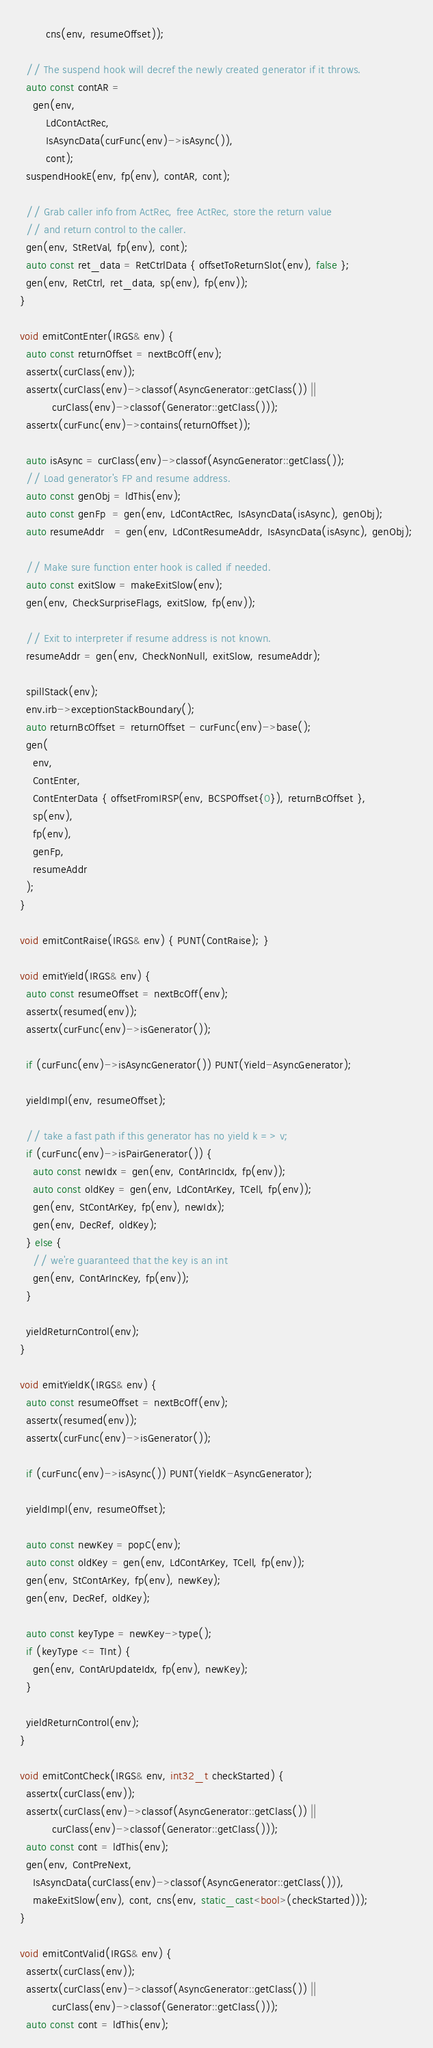<code> <loc_0><loc_0><loc_500><loc_500><_C++_>        cns(env, resumeOffset));

  // The suspend hook will decref the newly created generator if it throws.
  auto const contAR =
    gen(env,
        LdContActRec,
        IsAsyncData(curFunc(env)->isAsync()),
        cont);
  suspendHookE(env, fp(env), contAR, cont);

  // Grab caller info from ActRec, free ActRec, store the return value
  // and return control to the caller.
  gen(env, StRetVal, fp(env), cont);
  auto const ret_data = RetCtrlData { offsetToReturnSlot(env), false };
  gen(env, RetCtrl, ret_data, sp(env), fp(env));
}

void emitContEnter(IRGS& env) {
  auto const returnOffset = nextBcOff(env);
  assertx(curClass(env));
  assertx(curClass(env)->classof(AsyncGenerator::getClass()) ||
          curClass(env)->classof(Generator::getClass()));
  assertx(curFunc(env)->contains(returnOffset));

  auto isAsync = curClass(env)->classof(AsyncGenerator::getClass());
  // Load generator's FP and resume address.
  auto const genObj = ldThis(env);
  auto const genFp  = gen(env, LdContActRec, IsAsyncData(isAsync), genObj);
  auto resumeAddr   = gen(env, LdContResumeAddr, IsAsyncData(isAsync), genObj);

  // Make sure function enter hook is called if needed.
  auto const exitSlow = makeExitSlow(env);
  gen(env, CheckSurpriseFlags, exitSlow, fp(env));

  // Exit to interpreter if resume address is not known.
  resumeAddr = gen(env, CheckNonNull, exitSlow, resumeAddr);

  spillStack(env);
  env.irb->exceptionStackBoundary();
  auto returnBcOffset = returnOffset - curFunc(env)->base();
  gen(
    env,
    ContEnter,
    ContEnterData { offsetFromIRSP(env, BCSPOffset{0}), returnBcOffset },
    sp(env),
    fp(env),
    genFp,
    resumeAddr
  );
}

void emitContRaise(IRGS& env) { PUNT(ContRaise); }

void emitYield(IRGS& env) {
  auto const resumeOffset = nextBcOff(env);
  assertx(resumed(env));
  assertx(curFunc(env)->isGenerator());

  if (curFunc(env)->isAsyncGenerator()) PUNT(Yield-AsyncGenerator);

  yieldImpl(env, resumeOffset);

  // take a fast path if this generator has no yield k => v;
  if (curFunc(env)->isPairGenerator()) {
    auto const newIdx = gen(env, ContArIncIdx, fp(env));
    auto const oldKey = gen(env, LdContArKey, TCell, fp(env));
    gen(env, StContArKey, fp(env), newIdx);
    gen(env, DecRef, oldKey);
  } else {
    // we're guaranteed that the key is an int
    gen(env, ContArIncKey, fp(env));
  }

  yieldReturnControl(env);
}

void emitYieldK(IRGS& env) {
  auto const resumeOffset = nextBcOff(env);
  assertx(resumed(env));
  assertx(curFunc(env)->isGenerator());

  if (curFunc(env)->isAsync()) PUNT(YieldK-AsyncGenerator);

  yieldImpl(env, resumeOffset);

  auto const newKey = popC(env);
  auto const oldKey = gen(env, LdContArKey, TCell, fp(env));
  gen(env, StContArKey, fp(env), newKey);
  gen(env, DecRef, oldKey);

  auto const keyType = newKey->type();
  if (keyType <= TInt) {
    gen(env, ContArUpdateIdx, fp(env), newKey);
  }

  yieldReturnControl(env);
}

void emitContCheck(IRGS& env, int32_t checkStarted) {
  assertx(curClass(env));
  assertx(curClass(env)->classof(AsyncGenerator::getClass()) ||
          curClass(env)->classof(Generator::getClass()));
  auto const cont = ldThis(env);
  gen(env, ContPreNext,
    IsAsyncData(curClass(env)->classof(AsyncGenerator::getClass())),
    makeExitSlow(env), cont, cns(env, static_cast<bool>(checkStarted)));
}

void emitContValid(IRGS& env) {
  assertx(curClass(env));
  assertx(curClass(env)->classof(AsyncGenerator::getClass()) ||
          curClass(env)->classof(Generator::getClass()));
  auto const cont = ldThis(env);</code> 